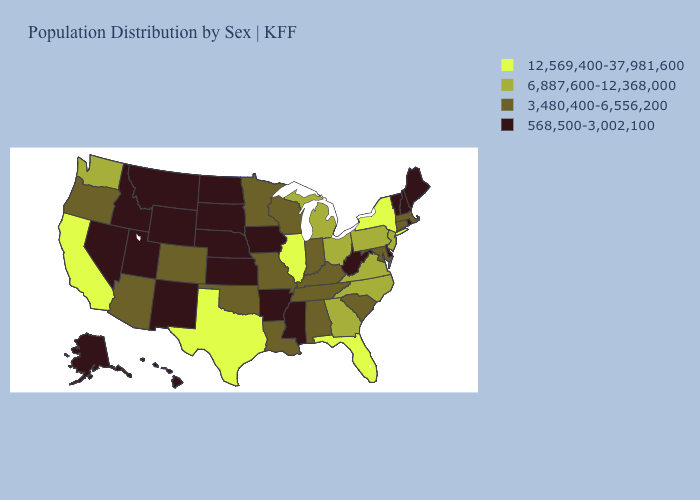Name the states that have a value in the range 6,887,600-12,368,000?
Keep it brief. Georgia, Michigan, New Jersey, North Carolina, Ohio, Pennsylvania, Virginia, Washington. Among the states that border California , which have the highest value?
Quick response, please. Arizona, Oregon. Among the states that border Virginia , which have the highest value?
Concise answer only. North Carolina. Does Nevada have a higher value than Illinois?
Give a very brief answer. No. What is the value of Nevada?
Answer briefly. 568,500-3,002,100. Does West Virginia have a lower value than Mississippi?
Keep it brief. No. Name the states that have a value in the range 568,500-3,002,100?
Quick response, please. Alaska, Arkansas, Delaware, Hawaii, Idaho, Iowa, Kansas, Maine, Mississippi, Montana, Nebraska, Nevada, New Hampshire, New Mexico, North Dakota, Rhode Island, South Dakota, Utah, Vermont, West Virginia, Wyoming. What is the value of North Dakota?
Be succinct. 568,500-3,002,100. Which states have the highest value in the USA?
Keep it brief. California, Florida, Illinois, New York, Texas. Does Texas have the highest value in the South?
Give a very brief answer. Yes. Among the states that border Wyoming , which have the lowest value?
Short answer required. Idaho, Montana, Nebraska, South Dakota, Utah. Which states have the lowest value in the MidWest?
Quick response, please. Iowa, Kansas, Nebraska, North Dakota, South Dakota. Name the states that have a value in the range 12,569,400-37,981,600?
Concise answer only. California, Florida, Illinois, New York, Texas. What is the highest value in the West ?
Keep it brief. 12,569,400-37,981,600. What is the value of Ohio?
Quick response, please. 6,887,600-12,368,000. 